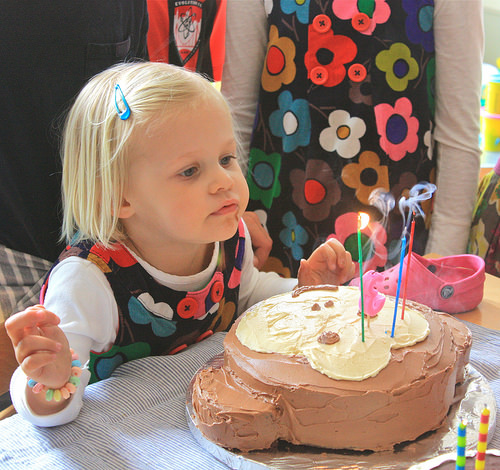<image>
Can you confirm if the shoe is on the table? Yes. Looking at the image, I can see the shoe is positioned on top of the table, with the table providing support. 